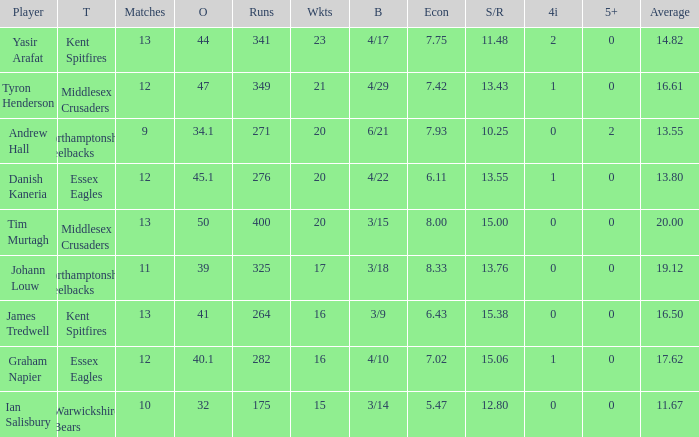Name the most wickets for best is 4/22 20.0. 